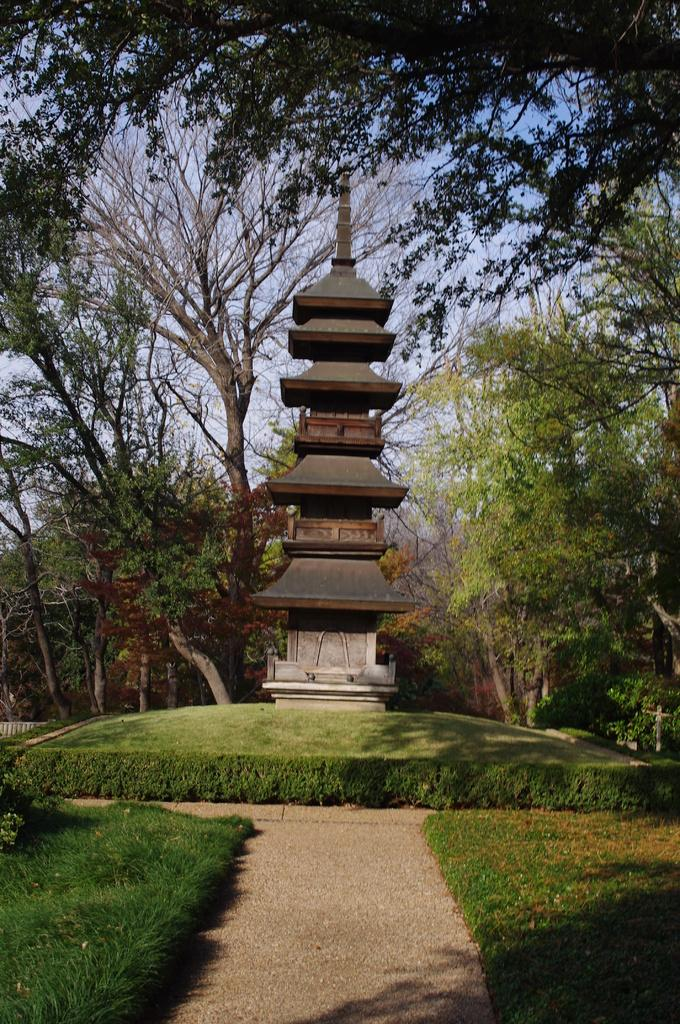What is the main structure in the image? There is a tower in the image. What can be seen in the background of the image? There are trees in the background of the image. What color are the trees? The trees are green. What color is the sky in the image? The sky is blue. How many tickets are visible in the image? There are no tickets present in the image. Is there a rabbit hiding among the trees in the image? There is no rabbit present in the image; only trees are visible in the background. 